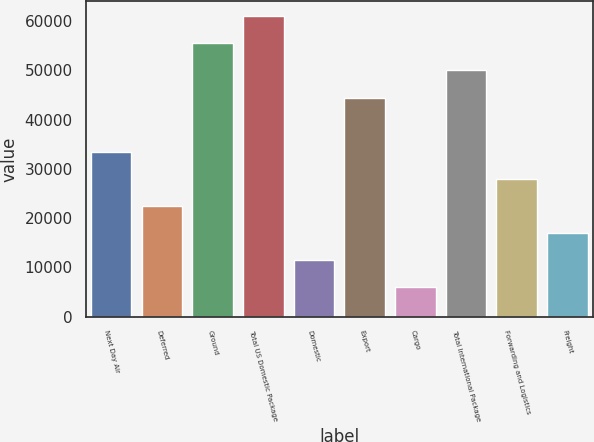Convert chart. <chart><loc_0><loc_0><loc_500><loc_500><bar_chart><fcel>Next Day Air<fcel>Deferred<fcel>Ground<fcel>Total US Domestic Package<fcel>Domestic<fcel>Export<fcel>Cargo<fcel>Total International Package<fcel>Forwarding and Logistics<fcel>Freight<nl><fcel>33487.2<fcel>22511.8<fcel>55438<fcel>60925.7<fcel>11536.4<fcel>44462.6<fcel>6048.7<fcel>49950.3<fcel>27999.5<fcel>17024.1<nl></chart> 